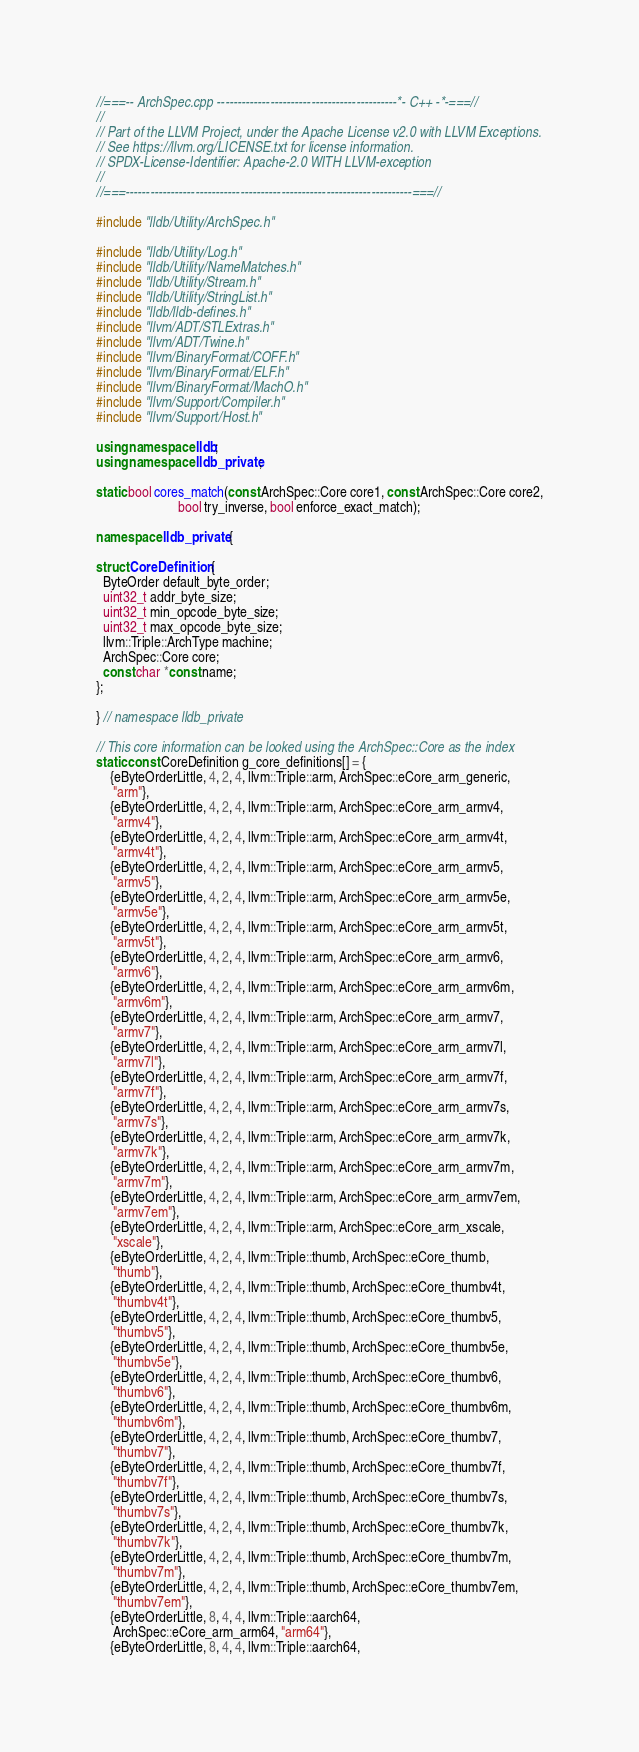<code> <loc_0><loc_0><loc_500><loc_500><_C++_>//===-- ArchSpec.cpp --------------------------------------------*- C++ -*-===//
//
// Part of the LLVM Project, under the Apache License v2.0 with LLVM Exceptions.
// See https://llvm.org/LICENSE.txt for license information.
// SPDX-License-Identifier: Apache-2.0 WITH LLVM-exception
//
//===----------------------------------------------------------------------===//

#include "lldb/Utility/ArchSpec.h"

#include "lldb/Utility/Log.h"
#include "lldb/Utility/NameMatches.h"
#include "lldb/Utility/Stream.h"
#include "lldb/Utility/StringList.h"
#include "lldb/lldb-defines.h"
#include "llvm/ADT/STLExtras.h"
#include "llvm/ADT/Twine.h"
#include "llvm/BinaryFormat/COFF.h"
#include "llvm/BinaryFormat/ELF.h"
#include "llvm/BinaryFormat/MachO.h"
#include "llvm/Support/Compiler.h"
#include "llvm/Support/Host.h"

using namespace lldb;
using namespace lldb_private;

static bool cores_match(const ArchSpec::Core core1, const ArchSpec::Core core2,
                        bool try_inverse, bool enforce_exact_match);

namespace lldb_private {

struct CoreDefinition {
  ByteOrder default_byte_order;
  uint32_t addr_byte_size;
  uint32_t min_opcode_byte_size;
  uint32_t max_opcode_byte_size;
  llvm::Triple::ArchType machine;
  ArchSpec::Core core;
  const char *const name;
};

} // namespace lldb_private

// This core information can be looked using the ArchSpec::Core as the index
static const CoreDefinition g_core_definitions[] = {
    {eByteOrderLittle, 4, 2, 4, llvm::Triple::arm, ArchSpec::eCore_arm_generic,
     "arm"},
    {eByteOrderLittle, 4, 2, 4, llvm::Triple::arm, ArchSpec::eCore_arm_armv4,
     "armv4"},
    {eByteOrderLittle, 4, 2, 4, llvm::Triple::arm, ArchSpec::eCore_arm_armv4t,
     "armv4t"},
    {eByteOrderLittle, 4, 2, 4, llvm::Triple::arm, ArchSpec::eCore_arm_armv5,
     "armv5"},
    {eByteOrderLittle, 4, 2, 4, llvm::Triple::arm, ArchSpec::eCore_arm_armv5e,
     "armv5e"},
    {eByteOrderLittle, 4, 2, 4, llvm::Triple::arm, ArchSpec::eCore_arm_armv5t,
     "armv5t"},
    {eByteOrderLittle, 4, 2, 4, llvm::Triple::arm, ArchSpec::eCore_arm_armv6,
     "armv6"},
    {eByteOrderLittle, 4, 2, 4, llvm::Triple::arm, ArchSpec::eCore_arm_armv6m,
     "armv6m"},
    {eByteOrderLittle, 4, 2, 4, llvm::Triple::arm, ArchSpec::eCore_arm_armv7,
     "armv7"},
    {eByteOrderLittle, 4, 2, 4, llvm::Triple::arm, ArchSpec::eCore_arm_armv7l,
     "armv7l"},
    {eByteOrderLittle, 4, 2, 4, llvm::Triple::arm, ArchSpec::eCore_arm_armv7f,
     "armv7f"},
    {eByteOrderLittle, 4, 2, 4, llvm::Triple::arm, ArchSpec::eCore_arm_armv7s,
     "armv7s"},
    {eByteOrderLittle, 4, 2, 4, llvm::Triple::arm, ArchSpec::eCore_arm_armv7k,
     "armv7k"},
    {eByteOrderLittle, 4, 2, 4, llvm::Triple::arm, ArchSpec::eCore_arm_armv7m,
     "armv7m"},
    {eByteOrderLittle, 4, 2, 4, llvm::Triple::arm, ArchSpec::eCore_arm_armv7em,
     "armv7em"},
    {eByteOrderLittle, 4, 2, 4, llvm::Triple::arm, ArchSpec::eCore_arm_xscale,
     "xscale"},
    {eByteOrderLittle, 4, 2, 4, llvm::Triple::thumb, ArchSpec::eCore_thumb,
     "thumb"},
    {eByteOrderLittle, 4, 2, 4, llvm::Triple::thumb, ArchSpec::eCore_thumbv4t,
     "thumbv4t"},
    {eByteOrderLittle, 4, 2, 4, llvm::Triple::thumb, ArchSpec::eCore_thumbv5,
     "thumbv5"},
    {eByteOrderLittle, 4, 2, 4, llvm::Triple::thumb, ArchSpec::eCore_thumbv5e,
     "thumbv5e"},
    {eByteOrderLittle, 4, 2, 4, llvm::Triple::thumb, ArchSpec::eCore_thumbv6,
     "thumbv6"},
    {eByteOrderLittle, 4, 2, 4, llvm::Triple::thumb, ArchSpec::eCore_thumbv6m,
     "thumbv6m"},
    {eByteOrderLittle, 4, 2, 4, llvm::Triple::thumb, ArchSpec::eCore_thumbv7,
     "thumbv7"},
    {eByteOrderLittle, 4, 2, 4, llvm::Triple::thumb, ArchSpec::eCore_thumbv7f,
     "thumbv7f"},
    {eByteOrderLittle, 4, 2, 4, llvm::Triple::thumb, ArchSpec::eCore_thumbv7s,
     "thumbv7s"},
    {eByteOrderLittle, 4, 2, 4, llvm::Triple::thumb, ArchSpec::eCore_thumbv7k,
     "thumbv7k"},
    {eByteOrderLittle, 4, 2, 4, llvm::Triple::thumb, ArchSpec::eCore_thumbv7m,
     "thumbv7m"},
    {eByteOrderLittle, 4, 2, 4, llvm::Triple::thumb, ArchSpec::eCore_thumbv7em,
     "thumbv7em"},
    {eByteOrderLittle, 8, 4, 4, llvm::Triple::aarch64,
     ArchSpec::eCore_arm_arm64, "arm64"},
    {eByteOrderLittle, 8, 4, 4, llvm::Triple::aarch64,</code> 